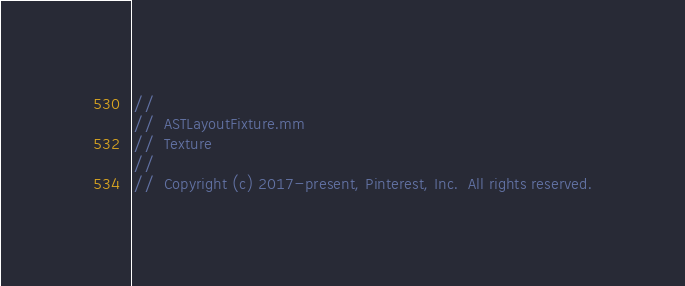<code> <loc_0><loc_0><loc_500><loc_500><_ObjectiveC_>//
//  ASTLayoutFixture.mm
//  Texture
//
//  Copyright (c) 2017-present, Pinterest, Inc.  All rights reserved.</code> 